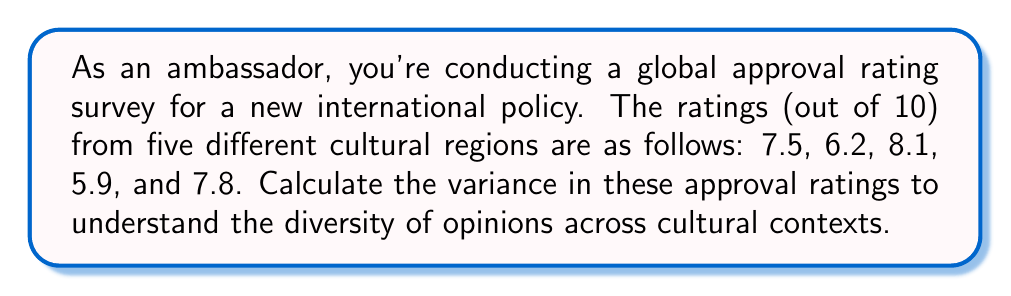What is the answer to this math problem? To calculate the variance, we'll follow these steps:

1. Calculate the mean (average) of the approval ratings:
   $$\bar{x} = \frac{7.5 + 6.2 + 8.1 + 5.9 + 7.8}{5} = 7.1$$

2. Calculate the squared differences from the mean:
   $$(7.5 - 7.1)^2 = 0.16$$
   $$(6.2 - 7.1)^2 = 0.81$$
   $$(8.1 - 7.1)^2 = 1.00$$
   $$(5.9 - 7.1)^2 = 1.44$$
   $$(7.8 - 7.1)^2 = 0.49$$

3. Sum the squared differences:
   $$0.16 + 0.81 + 1.00 + 1.44 + 0.49 = 3.90$$

4. Divide by the number of samples (n) to get the variance:
   $$\text{Variance} = \frac{3.90}{5} = 0.78$$

The formula for variance is:
$$\text{Variance} = \frac{\sum_{i=1}^{n} (x_i - \bar{x})^2}{n}$$

Where $x_i$ are the individual values, $\bar{x}$ is the mean, and $n$ is the number of samples.
Answer: The variance in approval ratings across different cultural contexts is 0.78. 